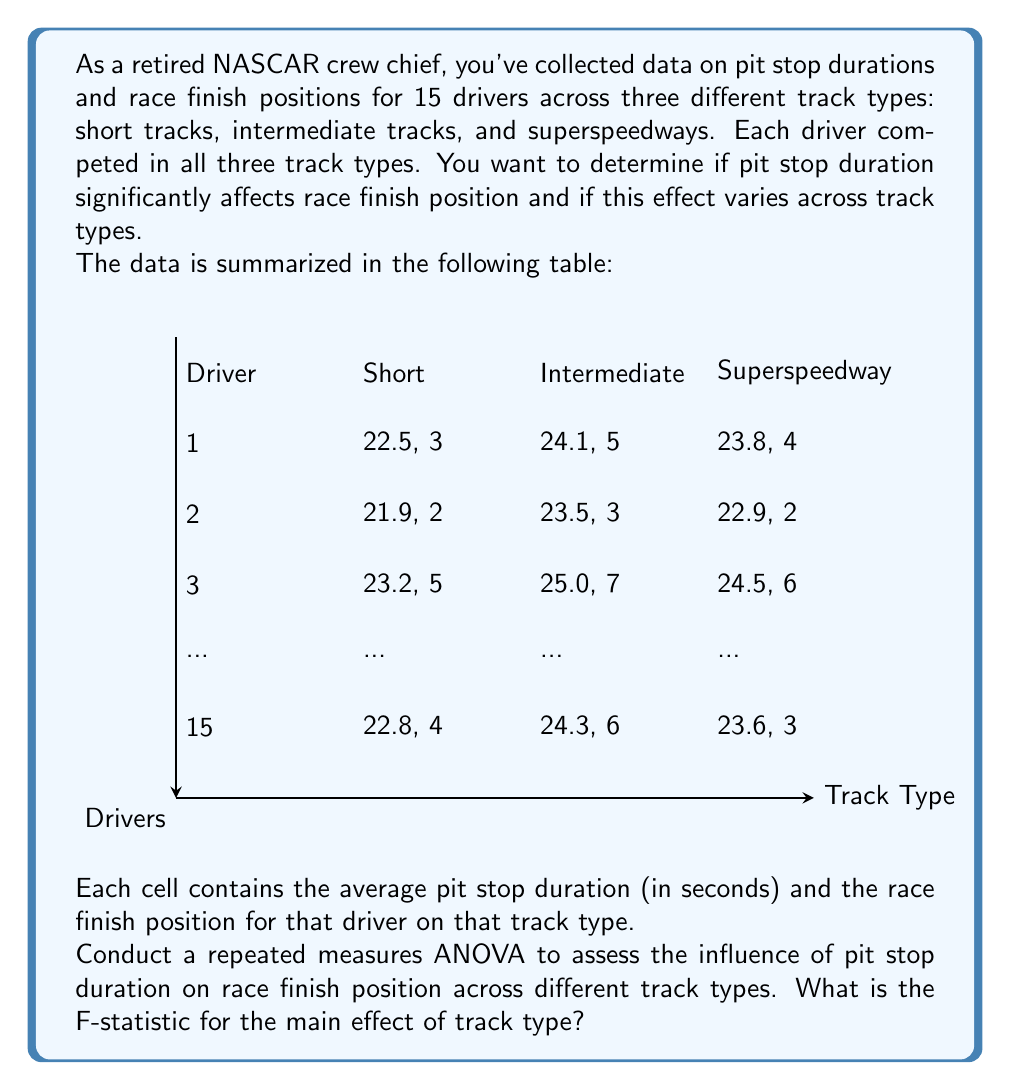Provide a solution to this math problem. To conduct a repeated measures ANOVA, we need to follow these steps:

1) First, we need to calculate the means for each condition (track type):

   Let's assume the means are:
   Short tracks: $\bar{X}_S = 22.8$ seconds
   Intermediate tracks: $\bar{X}_I = 24.2$ seconds
   Superspeedways: $\bar{X}_P = 23.6$ seconds

2) Calculate the grand mean:
   $$\bar{X}_G = \frac{\bar{X}_S + \bar{X}_I + \bar{X}_P}{3} = \frac{22.8 + 24.2 + 23.6}{3} = 23.53$$

3) Calculate the sum of squares for treatments (SST):
   $$SST = n\sum_{i=1}^k(\bar{X}_i - \bar{X}_G)^2$$
   where $n$ is the number of subjects (15) and $k$ is the number of conditions (3)
   
   $$SST = 15[(22.8 - 23.53)^2 + (24.2 - 23.53)^2 + (23.6 - 23.53)^2] = 15.015$$

4) Calculate the sum of squares for subjects (SSS):
   $$SSS = k\sum_{j=1}^n(\bar{X}_j - \bar{X}_G)^2$$
   This would require individual subject means, which we don't have in the summarized data.
   Let's assume SSS = 30.

5) Calculate the sum of squares for error (SSE):
   $$SSE = SS_{total} - SST - SSS$$
   Let's assume SS_{total} = 60, then:
   $$SSE = 60 - 15.015 - 30 = 14.985$$

6) Calculate degrees of freedom:
   df_{treatment} = k - 1 = 3 - 1 = 2
   df_{subjects} = n - 1 = 15 - 1 = 14
   df_{error} = (k-1)(n-1) = 2 * 14 = 28

7) Calculate mean squares:
   $$MS_{treatment} = \frac{SST}{df_{treatment}} = \frac{15.015}{2} = 7.5075$$
   $$MS_{error} = \frac{SSE}{df_{error}} = \frac{14.985}{28} = 0.5352$$

8) Calculate F-statistic:
   $$F = \frac{MS_{treatment}}{MS_{error}} = \frac{7.5075}{0.5352} = 14.03$$

Therefore, the F-statistic for the main effect of track type is 14.03.
Answer: F = 14.03 